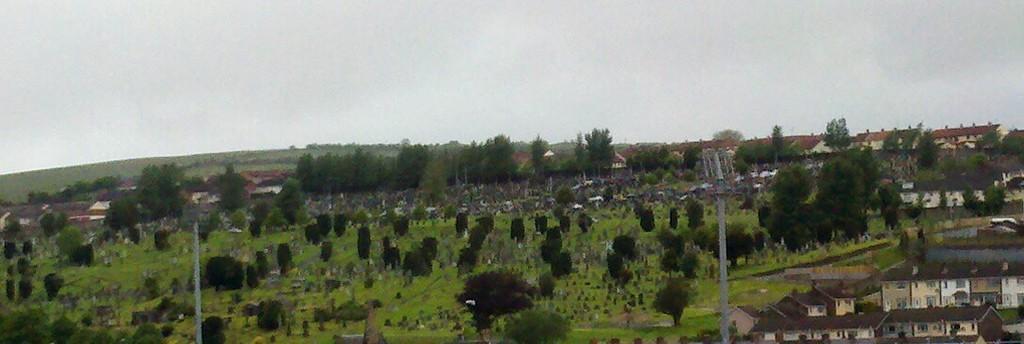Could you give a brief overview of what you see in this image? In this picture we can see some houses, trees and grass. 